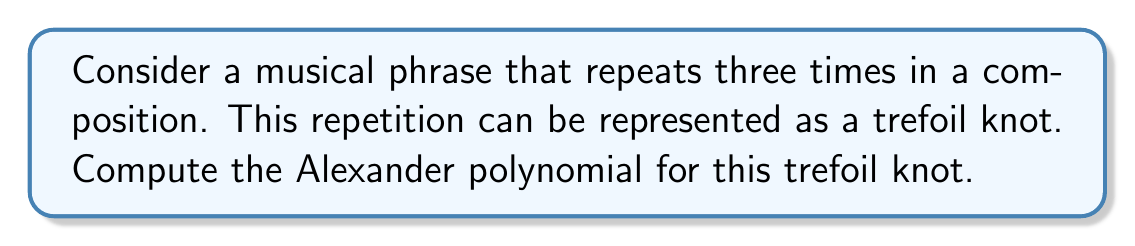Could you help me with this problem? Let's approach this step-by-step:

1) First, we need to create a diagram of the trefoil knot. The trefoil knot has three crossings.

2) We then need to label the arcs and assign variables to the crossings. Let's label the arcs a, b, and c, and assign variables t to each crossing.

3) Now we can create the Alexander matrix. For a trefoil knot, this will be a 3x3 matrix:

   $$
   \begin{pmatrix}
   1-t & t & 0 \\
   0 & 1-t & t \\
   t & 0 & 1-t
   \end{pmatrix}
   $$

4) To find the Alexander polynomial, we need to calculate the determinant of any 2x2 minor of this matrix and divide by $(t-1)$.

5) Let's choose the minor formed by deleting the first row and first column:

   $$
   \det \begin{pmatrix}
   1-t & t \\
   0 & 1-t
   \end{pmatrix} = (1-t)^2
   $$

6) Now we divide by $(t-1)$:

   $$\frac{(1-t)^2}{t-1} = -(1-t)$$

7) Finally, we multiply by $-1$ to get the standard form:

   $$\Delta(t) = 1-t+t^2$$

This polynomial, $1-t+t^2$, is the Alexander polynomial for the trefoil knot.
Answer: $\Delta(t) = 1-t+t^2$ 